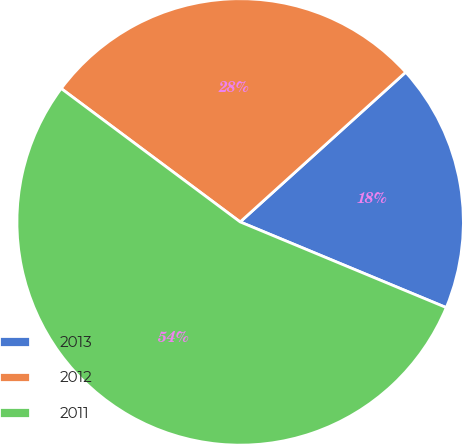<chart> <loc_0><loc_0><loc_500><loc_500><pie_chart><fcel>2013<fcel>2012<fcel>2011<nl><fcel>17.97%<fcel>28.1%<fcel>53.92%<nl></chart> 